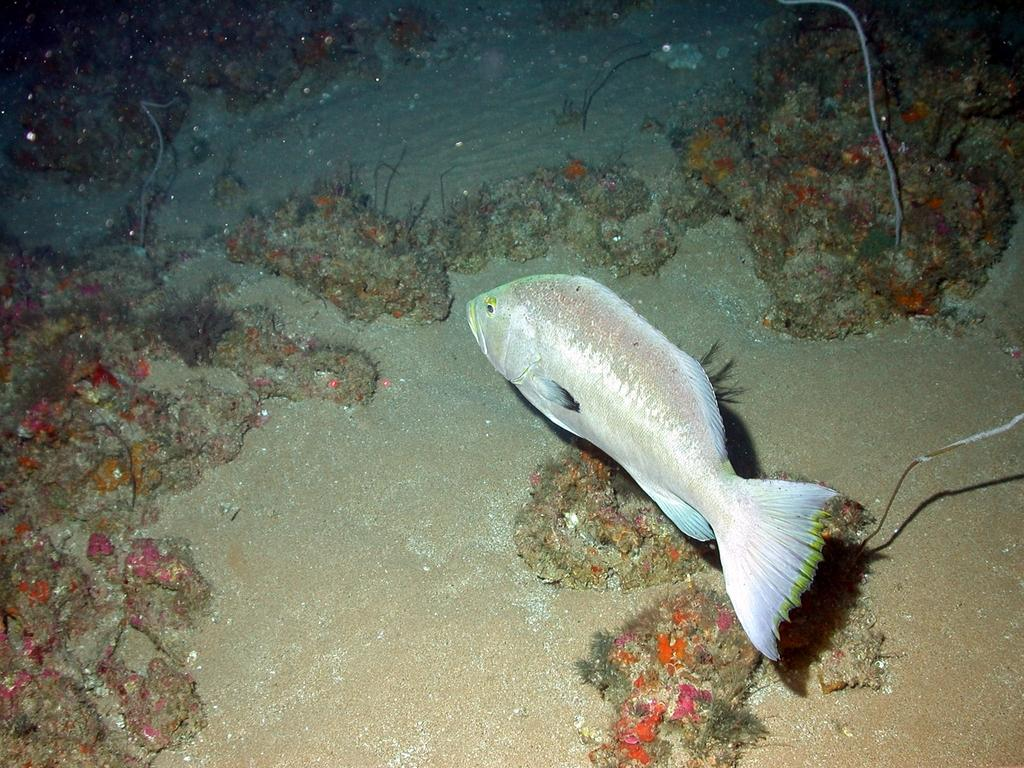What type of animal is in the image? There is a fish in the image. Where is the fish located? The fish is in water. What can be seen in the background of the image? There are stones and sand in the background of the image. What sound does the moon make in the image? There is no moon present in the image, so it cannot make any sound. 